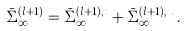<formula> <loc_0><loc_0><loc_500><loc_500>\bar { \Sigma } _ { \infty } ^ { ( l + 1 ) } = \bar { \Sigma } _ { \infty } ^ { ( l + 1 ) , t } + \bar { \Sigma } _ { \infty } ^ { ( l + 1 ) , u } \, .</formula> 